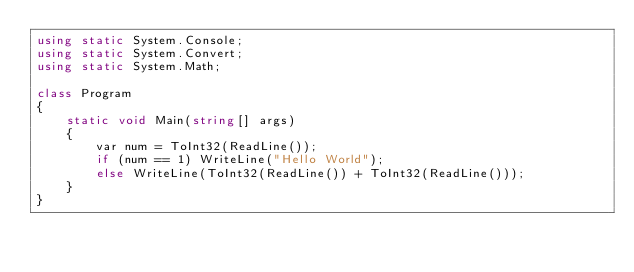<code> <loc_0><loc_0><loc_500><loc_500><_C#_>using static System.Console;
using static System.Convert;
using static System.Math;

class Program
{
    static void Main(string[] args)
    {
        var num = ToInt32(ReadLine());
        if (num == 1) WriteLine("Hello World");
        else WriteLine(ToInt32(ReadLine()) + ToInt32(ReadLine()));
    }
}
</code> 